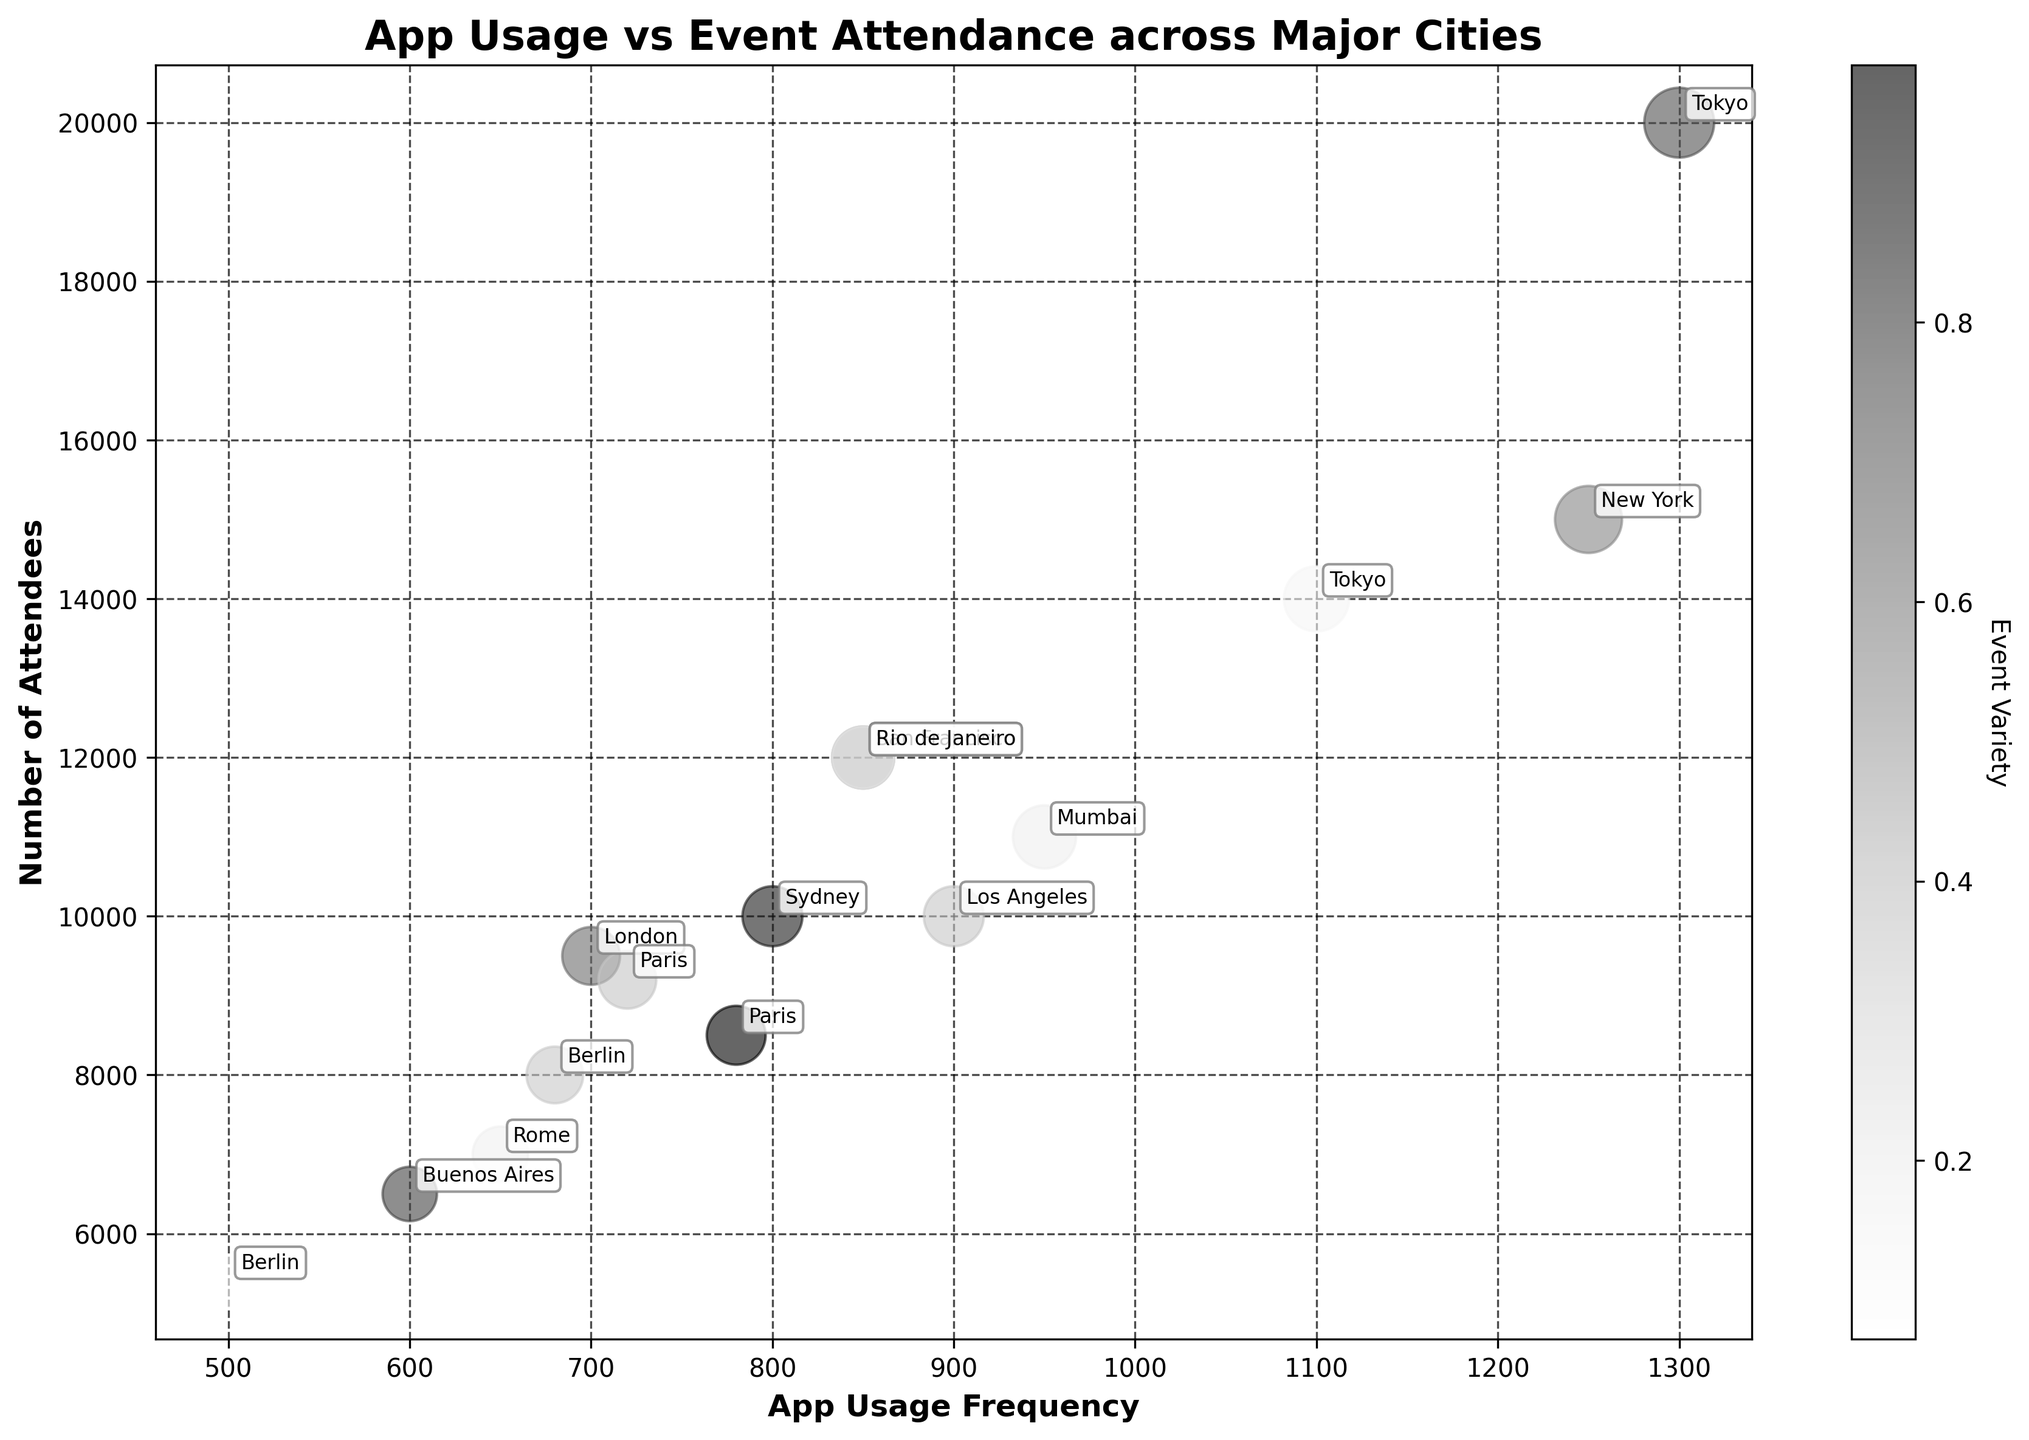What is the title of the plot? The title of the plot is located at the top and reads as "App Usage vs Event Attendance across Major Cities".
Answer: App Usage vs Event Attendance across Major Cities How many data points are represented in this bubble chart? Every bubble represents a data point, and counting all of them, we find that there are 15 data points.
Answer: 15 Which event has the highest app usage frequency? Looking at the horizontal axis (App Usage Frequency), the bubble with the highest value is for the "New Year Celebration" event in Tokyo.
Answer: New Year Celebration Which event has the largest number of attendees? By referring to the vertical axis (Number of Attendees), the largest value corresponds to the "New Year Celebration" event in Tokyo.
Answer: New Year Celebration What is the app usage frequency difference between the "Music Festival" in New York and the "Business Summit" in London? The app usage frequency for "Music Festival" in New York is 1250 and for "Business Summit" in London is 700. Subtracting them gives \( 1250 - 700 = 550 \).
Answer: 550 Which city appears twice in the list of events, and what are those events? By inspecting the labels attached to the bubbles, Paris appears twice with the events "Cultural Fair" and "Fashion Show".
Answer: Paris; Cultural Fair, Fashion Show Compare the app usage frequency between the events in San Francisco and Rio de Janeiro. Which one has a higher frequency? The app usage frequency for "Tech Conference" in San Francisco is 850 and for "Marathon" in Rio de Janeiro is also 850. Since they are equal, neither is higher.
Answer: Equal What is the median value of attendees for all events? To find the median, list all attendee counts in ascending order: 5400, 6500, 7000, 8000, 8500, 9200, 9500, 10000, 10000, 11000, 12000, 12000, 14000, 15000, 20000. The median is the 8th value, which is 10000.
Answer: 10000 Which event has the smallest bubble size and what is its corresponding event? The smallest bubble size can be identified visually and corresponds to the "Tech Meetup" event in Berlin.
Answer: Tech Meetup What is the relationship between the number of attendees and app usage frequency for the "Film Festival" in Mumbai? By observing the coordinates of the bubble representing "Film Festival" in Mumbai, the number of attendees is 11000, and the app usage frequency is 950.
Answer: 11000 attendees, 950 app usage frequency 